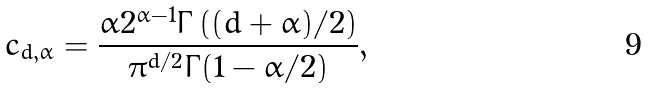Convert formula to latex. <formula><loc_0><loc_0><loc_500><loc_500>c _ { d , \alpha } = \frac { \alpha 2 ^ { \alpha - 1 } \Gamma \left ( ( d + \alpha ) / 2 \right ) } { \pi ^ { d / 2 } \Gamma ( 1 - \alpha / 2 ) } ,</formula> 